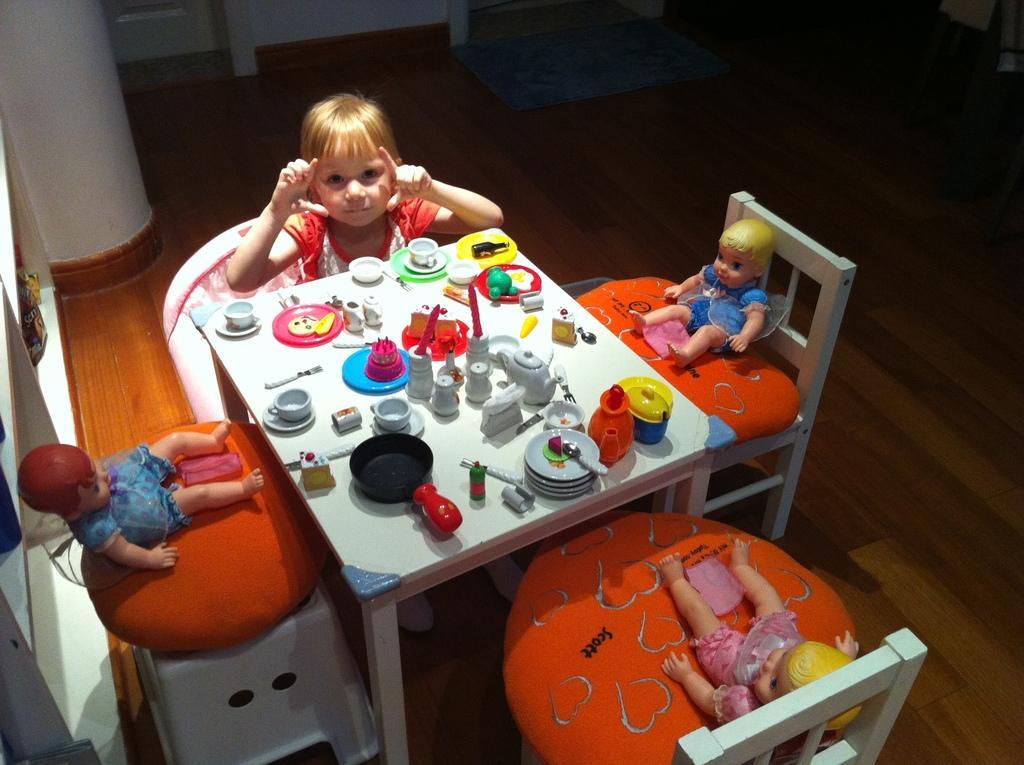Describe this image in one or two sentences. In this image we can see a girl sitting in front of the table and on the table we can see the playing objects. We can also see the toys placed on the chairs. In the background we can see the mat on the floor. 